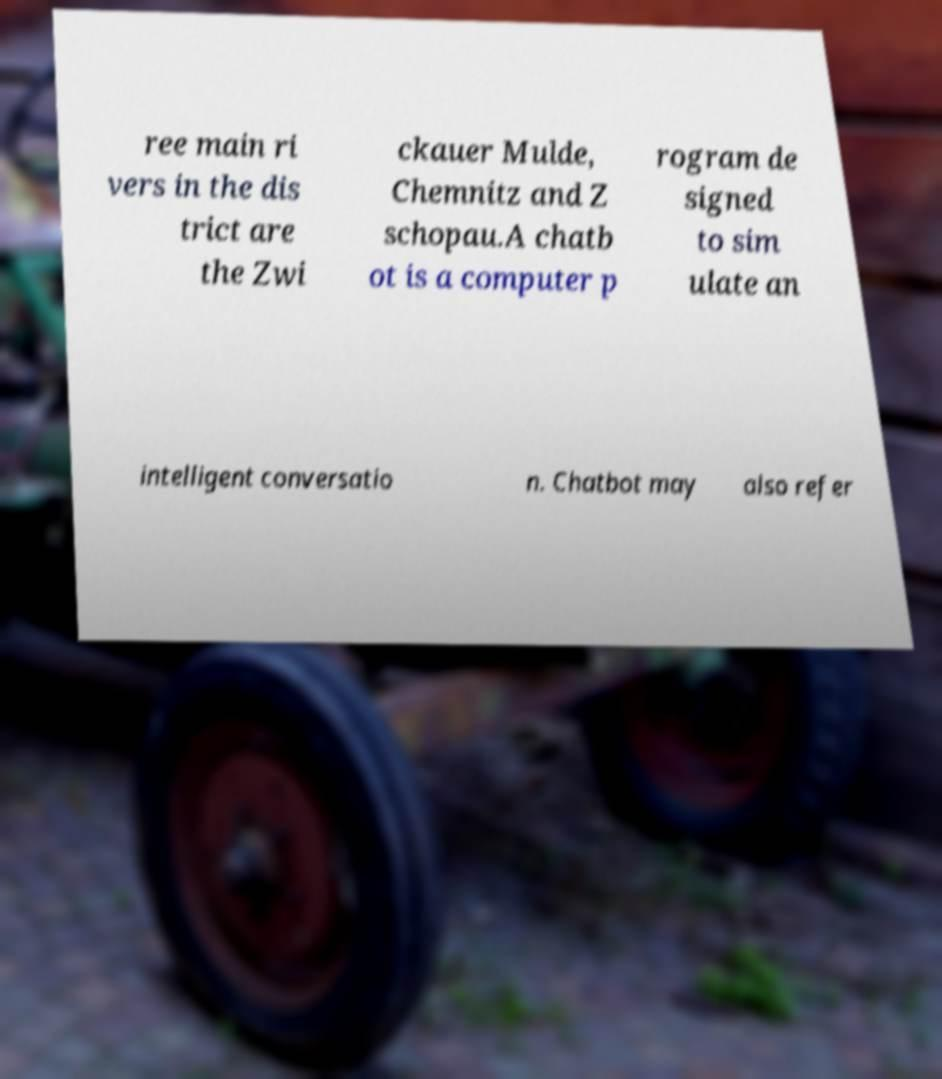I need the written content from this picture converted into text. Can you do that? ree main ri vers in the dis trict are the Zwi ckauer Mulde, Chemnitz and Z schopau.A chatb ot is a computer p rogram de signed to sim ulate an intelligent conversatio n. Chatbot may also refer 